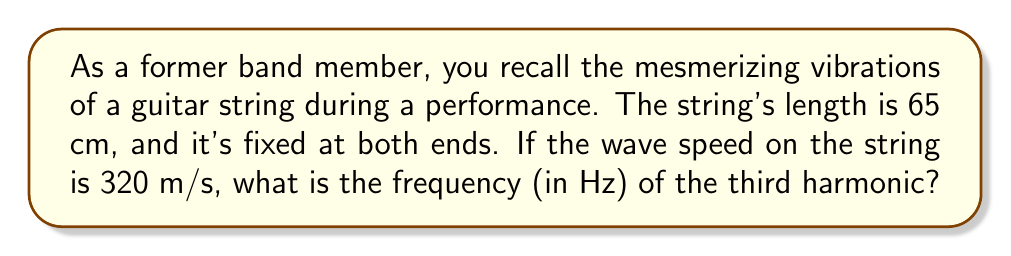What is the answer to this math problem? Let's approach this step-by-step using the one-dimensional wave equation:

1) For a string fixed at both ends, the wave equation solution gives us the harmonic frequencies:

   $$f_n = \frac{n v}{2L}$$

   where $f_n$ is the frequency of the nth harmonic, $v$ is the wave speed, and $L$ is the length of the string.

2) We're asked about the third harmonic, so $n = 3$.

3) Given:
   - Length of string, $L = 65$ cm = 0.65 m
   - Wave speed, $v = 320$ m/s
   - We want the 3rd harmonic, so $n = 3$

4) Let's substitute these values into our equation:

   $$f_3 = \frac{3 \cdot 320}{2 \cdot 0.65}$$

5) Simplify:
   
   $$f_3 = \frac{960}{1.3} = 738.46153846$$

6) Rounding to two decimal places:

   $$f_3 \approx 738.46 \text{ Hz}$$

This frequency corresponds to a pitch slightly higher than F#5 on a standard-tuned guitar.
Answer: 738.46 Hz 